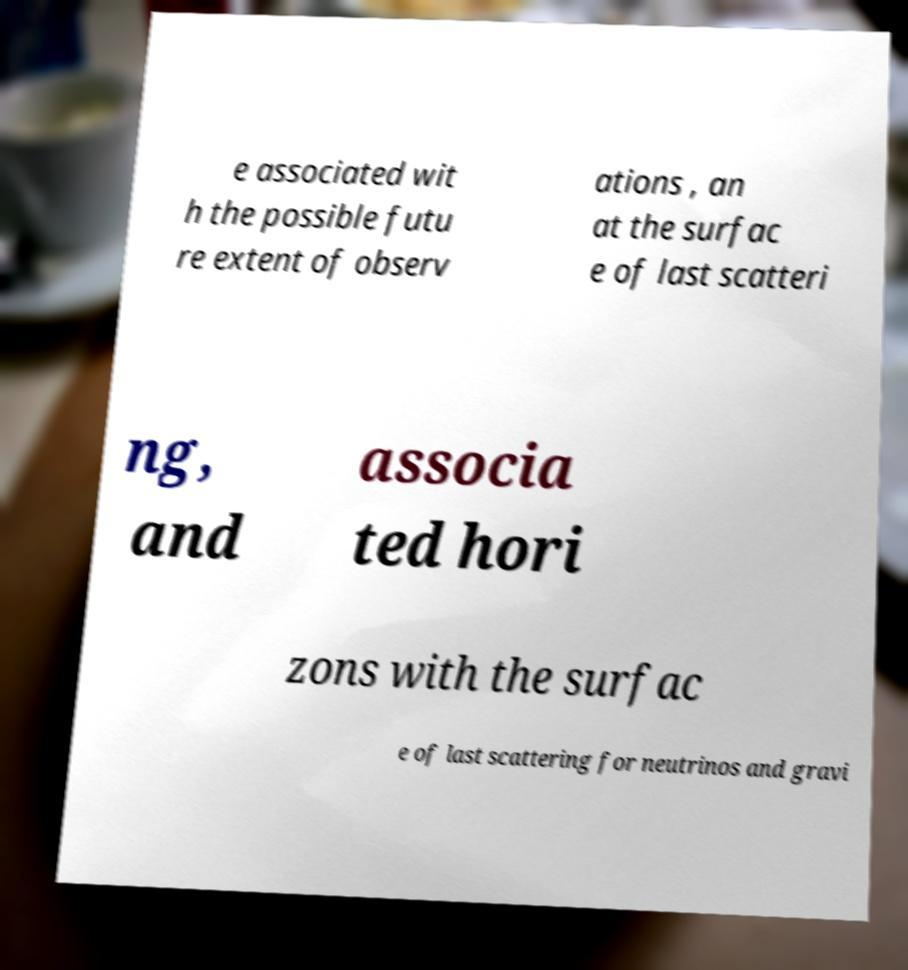I need the written content from this picture converted into text. Can you do that? e associated wit h the possible futu re extent of observ ations , an at the surfac e of last scatteri ng, and associa ted hori zons with the surfac e of last scattering for neutrinos and gravi 